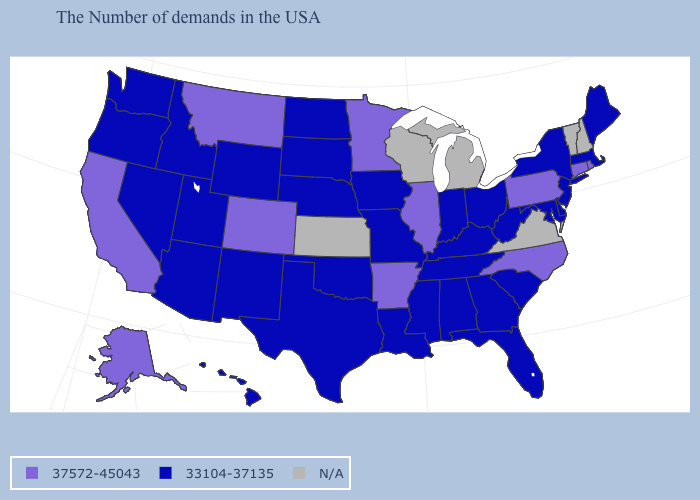Among the states that border Michigan , which have the highest value?
Concise answer only. Ohio, Indiana. Which states hav the highest value in the West?
Write a very short answer. Colorado, Montana, California, Alaska. Which states have the lowest value in the USA?
Keep it brief. Maine, Massachusetts, New York, New Jersey, Delaware, Maryland, South Carolina, West Virginia, Ohio, Florida, Georgia, Kentucky, Indiana, Alabama, Tennessee, Mississippi, Louisiana, Missouri, Iowa, Nebraska, Oklahoma, Texas, South Dakota, North Dakota, Wyoming, New Mexico, Utah, Arizona, Idaho, Nevada, Washington, Oregon, Hawaii. What is the value of California?
Concise answer only. 37572-45043. Name the states that have a value in the range 37572-45043?
Be succinct. Rhode Island, Connecticut, Pennsylvania, North Carolina, Illinois, Arkansas, Minnesota, Colorado, Montana, California, Alaska. What is the lowest value in states that border Connecticut?
Answer briefly. 33104-37135. Name the states that have a value in the range N/A?
Answer briefly. New Hampshire, Vermont, Virginia, Michigan, Wisconsin, Kansas. What is the value of Vermont?
Short answer required. N/A. Does the map have missing data?
Be succinct. Yes. Name the states that have a value in the range 33104-37135?
Be succinct. Maine, Massachusetts, New York, New Jersey, Delaware, Maryland, South Carolina, West Virginia, Ohio, Florida, Georgia, Kentucky, Indiana, Alabama, Tennessee, Mississippi, Louisiana, Missouri, Iowa, Nebraska, Oklahoma, Texas, South Dakota, North Dakota, Wyoming, New Mexico, Utah, Arizona, Idaho, Nevada, Washington, Oregon, Hawaii. Does Nevada have the lowest value in the USA?
Concise answer only. Yes. Which states hav the highest value in the South?
Answer briefly. North Carolina, Arkansas. What is the highest value in the MidWest ?
Short answer required. 37572-45043. What is the value of New York?
Keep it brief. 33104-37135. 